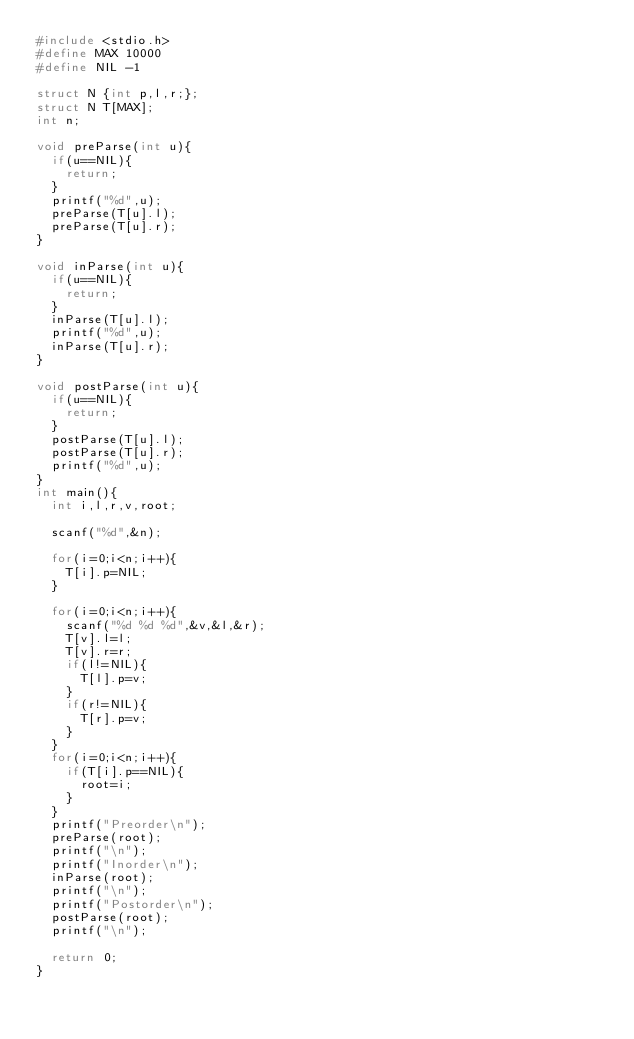<code> <loc_0><loc_0><loc_500><loc_500><_C_>#include <stdio.h>
#define MAX 10000
#define NIL -1

struct N {int p,l,r;};
struct N T[MAX];
int n;

void preParse(int u){
  if(u==NIL){
    return;
  }
  printf("%d",u);
  preParse(T[u].l);
  preParse(T[u].r);
}

void inParse(int u){
  if(u==NIL){
    return;
  }
  inParse(T[u].l);
  printf("%d",u);
  inParse(T[u].r);
}

void postParse(int u){
  if(u==NIL){
    return;
  }
  postParse(T[u].l);
  postParse(T[u].r);
  printf("%d",u);
}
int main(){
  int i,l,r,v,root;

  scanf("%d",&n);

  for(i=0;i<n;i++){
    T[i].p=NIL;
  }

  for(i=0;i<n;i++){
    scanf("%d %d %d",&v,&l,&r);
    T[v].l=l;
    T[v].r=r;
    if(l!=NIL){
      T[l].p=v;
    }
    if(r!=NIL){
      T[r].p=v;
    }
  }
  for(i=0;i<n;i++){
    if(T[i].p==NIL){
      root=i;
    }
  }
  printf("Preorder\n");
  preParse(root);
  printf("\n");
  printf("Inorder\n");
  inParse(root);
  printf("\n");
  printf("Postorder\n");
  postParse(root);
  printf("\n");

  return 0;
}</code> 